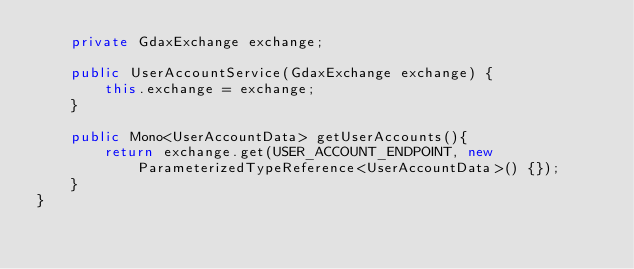Convert code to text. <code><loc_0><loc_0><loc_500><loc_500><_Java_>    private GdaxExchange exchange;

    public UserAccountService(GdaxExchange exchange) {
        this.exchange = exchange;
    }

    public Mono<UserAccountData> getUserAccounts(){
        return exchange.get(USER_ACCOUNT_ENDPOINT, new ParameterizedTypeReference<UserAccountData>() {});
    }
}
</code> 